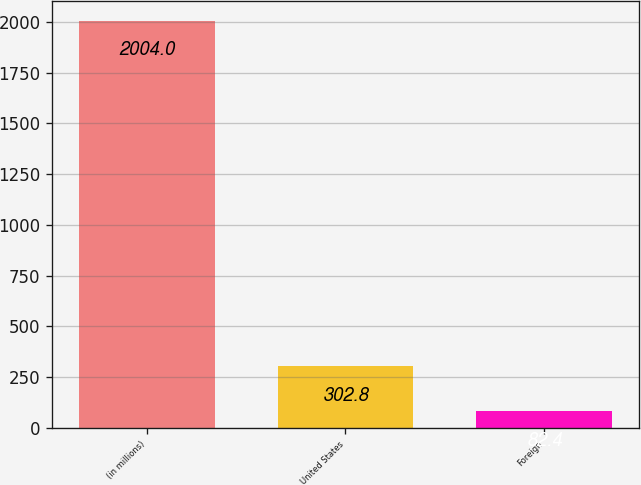Convert chart. <chart><loc_0><loc_0><loc_500><loc_500><bar_chart><fcel>(in millions)<fcel>United States<fcel>Foreign<nl><fcel>2004<fcel>302.8<fcel>82.4<nl></chart> 